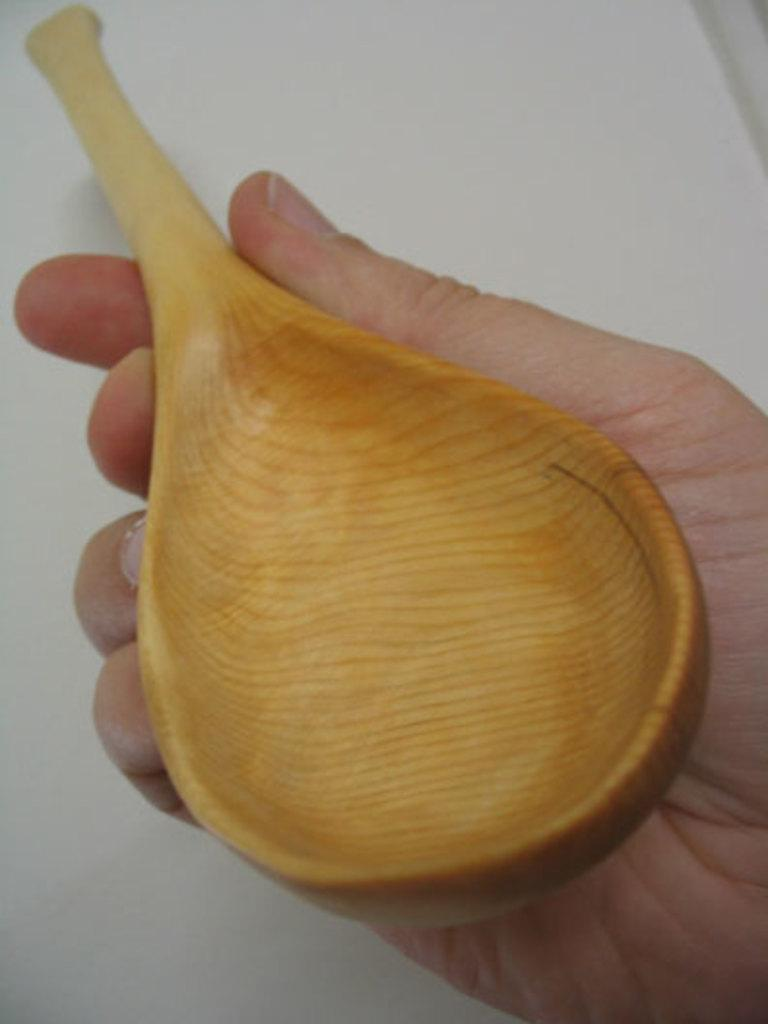What is the main subject of the image? The main subject of the image is a hand. To whom does the hand belong? The hand belongs to a person. What is the person holding in the image? The person is holding a spoon. What is the title of the cookbook that the person is holding in the image? There is no cookbook present in the image; the person is holding a spoon. How does the earthquake affect the person's hand in the image? There is no earthquake present in the image, so its effects on the person's hand cannot be determined. 